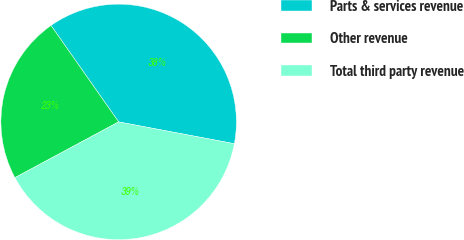Convert chart. <chart><loc_0><loc_0><loc_500><loc_500><pie_chart><fcel>Parts & services revenue<fcel>Other revenue<fcel>Total third party revenue<nl><fcel>37.7%<fcel>23.12%<fcel>39.19%<nl></chart> 